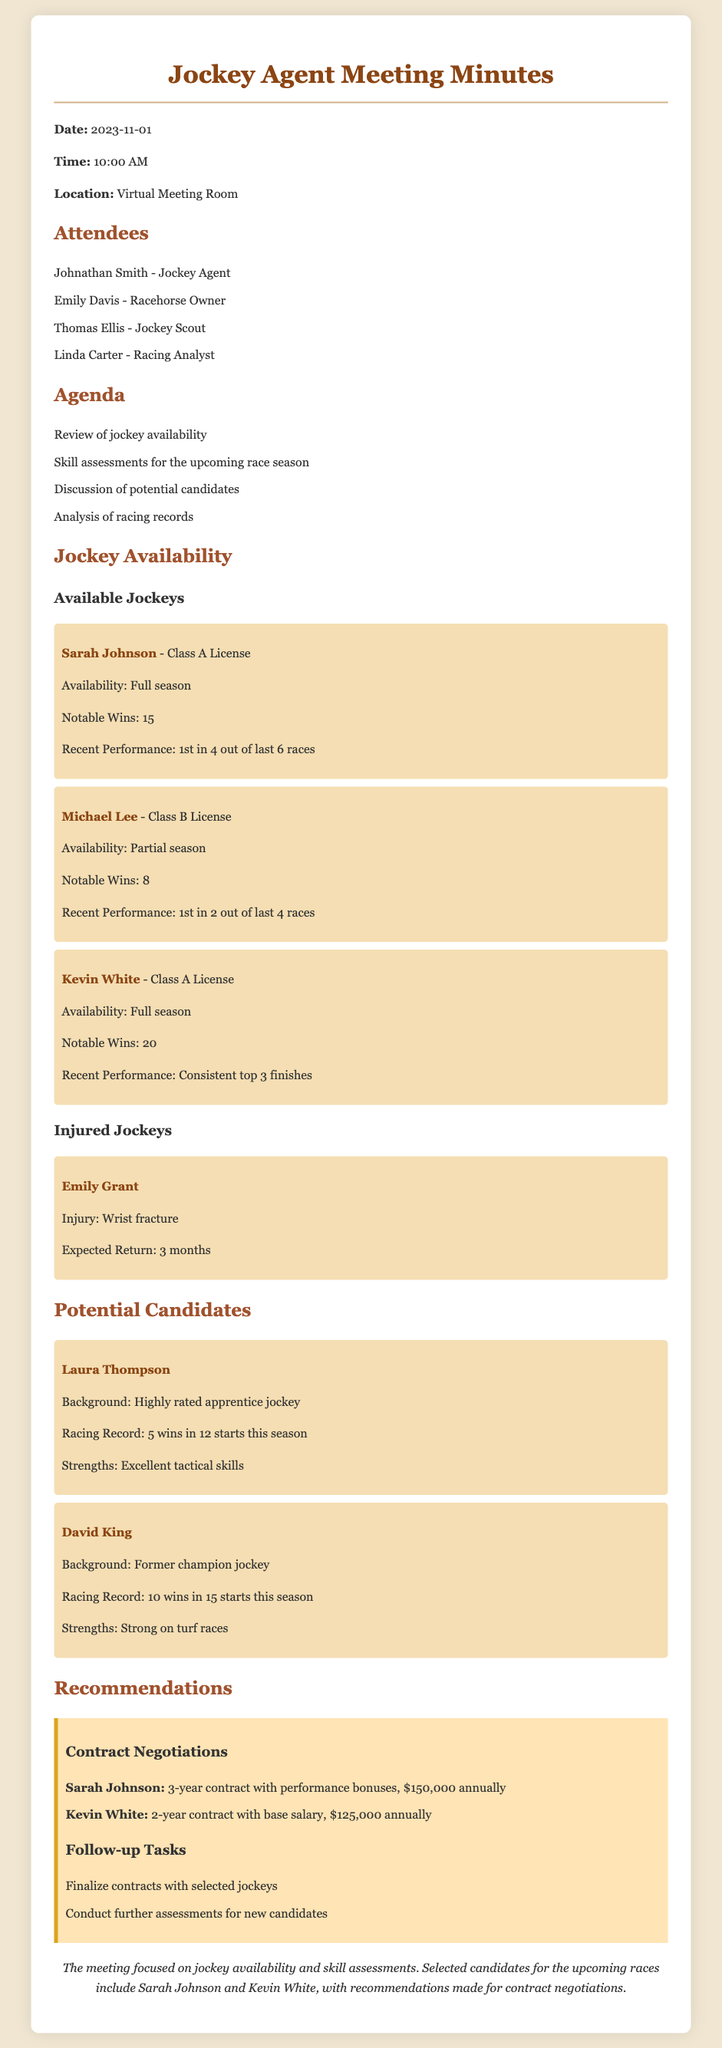What is the date of the meeting? The date of the meeting is explicitly stated in the document.
Answer: 2023-11-01 Who is the jockey scout attending the meeting? The document lists the attendees, including the jockey scout.
Answer: Thomas Ellis What is Sarah Johnson's license class? The document specifies the license class for each jockey.
Answer: Class A License How many notable wins does Kevin White have? The document provides the number of notable wins for each available jockey.
Answer: 20 What is the expected return time for Emily Grant? The document indicates the expected return time for injured jockeys.
Answer: 3 months Which jockey requires a performance bonus in their contract? The document states the recommended contracts for selected jockeys, including performance bonuses.
Answer: Sarah Johnson What is Laura Thompson's racing record this season? The document presents the racing record for potential candidates.
Answer: 5 wins in 12 starts How long is Kevin White's recommended contract? The document specifies the duration of the recommended contract for each jockey.
Answer: 2 years What is Linda Carter's role in the meeting? The roles of the attendees are mentioned in the document.
Answer: Racing Analyst 